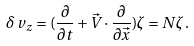Convert formula to latex. <formula><loc_0><loc_0><loc_500><loc_500>\delta \, v _ { z } = ( \frac { \partial } { \partial t } + \vec { V } \cdot \frac { \partial } { \partial \vec { x } } ) \zeta = N \zeta \, .</formula> 